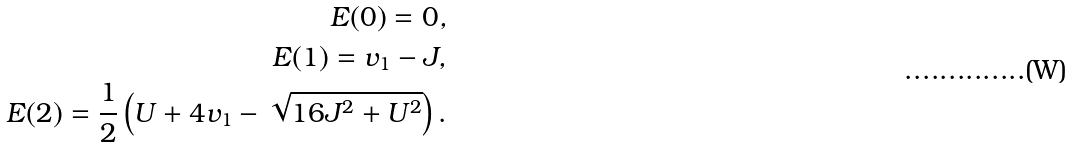Convert formula to latex. <formula><loc_0><loc_0><loc_500><loc_500>E ( 0 ) = 0 , \\ E ( 1 ) = v _ { 1 } - J , \\ E ( 2 ) = \frac { 1 } { 2 } \left ( U + 4 v _ { 1 } - \sqrt { 1 6 J ^ { 2 } + U ^ { 2 } } \right ) .</formula> 